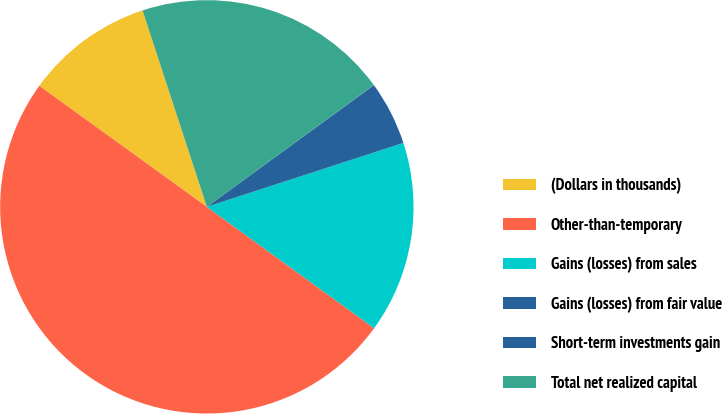<chart> <loc_0><loc_0><loc_500><loc_500><pie_chart><fcel>(Dollars in thousands)<fcel>Other-than-temporary<fcel>Gains (losses) from sales<fcel>Gains (losses) from fair value<fcel>Short-term investments gain<fcel>Total net realized capital<nl><fcel>10.01%<fcel>49.97%<fcel>15.0%<fcel>5.01%<fcel>0.02%<fcel>20.0%<nl></chart> 